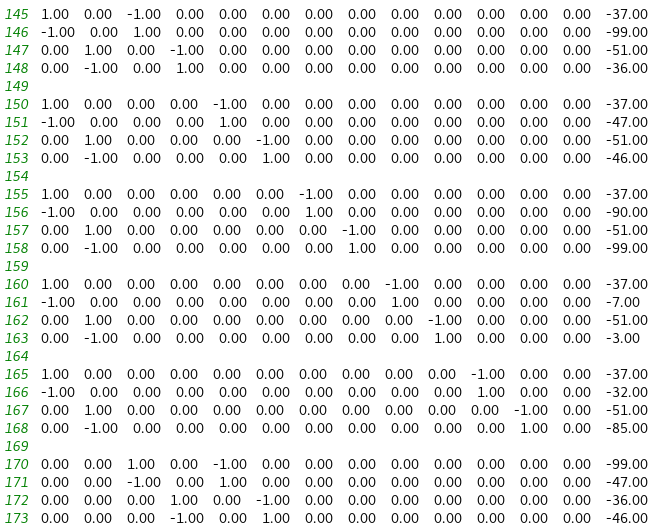Convert code to text. <code><loc_0><loc_0><loc_500><loc_500><_Matlab_>1.00	0.00	-1.00	0.00	0.00	0.00	0.00	0.00	0.00	0.00	0.00	0.00	0.00	-37.00
-1.00	0.00	1.00	0.00	0.00	0.00	0.00	0.00	0.00	0.00	0.00	0.00	0.00	-99.00
0.00	1.00	0.00	-1.00	0.00	0.00	0.00	0.00	0.00	0.00	0.00	0.00	0.00	-51.00
0.00	-1.00	0.00	1.00	0.00	0.00	0.00	0.00	0.00	0.00	0.00	0.00	0.00	-36.00

1.00	0.00	0.00	0.00	-1.00	0.00	0.00	0.00	0.00	0.00	0.00	0.00	0.00	-37.00
-1.00	0.00	0.00	0.00	1.00	0.00	0.00	0.00	0.00	0.00	0.00	0.00	0.00	-47.00
0.00	1.00	0.00	0.00	0.00	-1.00	0.00	0.00	0.00	0.00	0.00	0.00	0.00	-51.00
0.00	-1.00	0.00	0.00	0.00	1.00	0.00	0.00	0.00	0.00	0.00	0.00	0.00	-46.00

1.00	0.00	0.00	0.00	0.00	0.00	-1.00	0.00	0.00	0.00	0.00	0.00	0.00	-37.00
-1.00	0.00	0.00	0.00	0.00	0.00	1.00	0.00	0.00	0.00	0.00	0.00	0.00	-90.00
0.00	1.00	0.00	0.00	0.00	0.00	0.00	-1.00	0.00	0.00	0.00	0.00	0.00	-51.00
0.00	-1.00	0.00	0.00	0.00	0.00	0.00	1.00	0.00	0.00	0.00	0.00	0.00	-99.00

1.00	0.00	0.00	0.00	0.00	0.00	0.00	0.00	-1.00	0.00	0.00	0.00	0.00	-37.00
-1.00	0.00	0.00	0.00	0.00	0.00	0.00	0.00	1.00	0.00	0.00	0.00	0.00	-7.00
0.00	1.00	0.00	0.00	0.00	0.00	0.00	0.00	0.00	-1.00	0.00	0.00	0.00	-51.00
0.00	-1.00	0.00	0.00	0.00	0.00	0.00	0.00	0.00	1.00	0.00	0.00	0.00	-3.00

1.00	0.00	0.00	0.00	0.00	0.00	0.00	0.00	0.00	0.00	-1.00	0.00	0.00	-37.00
-1.00	0.00	0.00	0.00	0.00	0.00	0.00	0.00	0.00	0.00	1.00	0.00	0.00	-32.00
0.00	1.00	0.00	0.00	0.00	0.00	0.00	0.00	0.00	0.00	0.00	-1.00	0.00	-51.00
0.00	-1.00	0.00	0.00	0.00	0.00	0.00	0.00	0.00	0.00	0.00	1.00	0.00	-85.00

0.00	0.00	1.00	0.00	-1.00	0.00	0.00	0.00	0.00	0.00	0.00	0.00	0.00	-99.00
0.00	0.00	-1.00	0.00	1.00	0.00	0.00	0.00	0.00	0.00	0.00	0.00	0.00	-47.00
0.00	0.00	0.00	1.00	0.00	-1.00	0.00	0.00	0.00	0.00	0.00	0.00	0.00	-36.00
0.00	0.00	0.00	-1.00	0.00	1.00	0.00	0.00	0.00	0.00	0.00	0.00	0.00	-46.00
</code> 